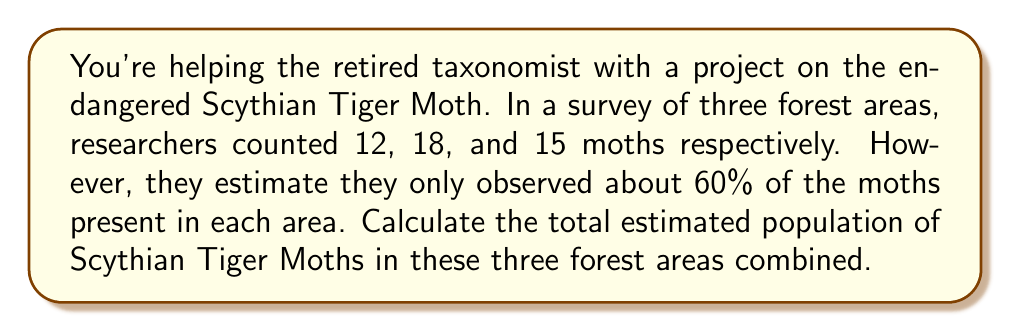What is the answer to this math problem? Let's approach this step-by-step:

1) First, let's calculate the total number of moths observed:
   $12 + 18 + 15 = 45$ moths

2) We know that this observed number represents only 60% of the actual population. To find the total population, we need to find what 100% would be.

3) We can set up the following equation:
   $45 = 0.60x$, where $x$ is the total population

4) To solve for $x$, we divide both sides by 0.60:
   $\frac{45}{0.60} = x$

5) Let's calculate this:
   $x = \frac{45}{0.60} = 75$

6) Therefore, the estimated total population in the three forest areas is 75 moths.

To verify:
60% of 75 is $75 \times 0.60 = 45$, which matches our observed count.
Answer: 75 moths 